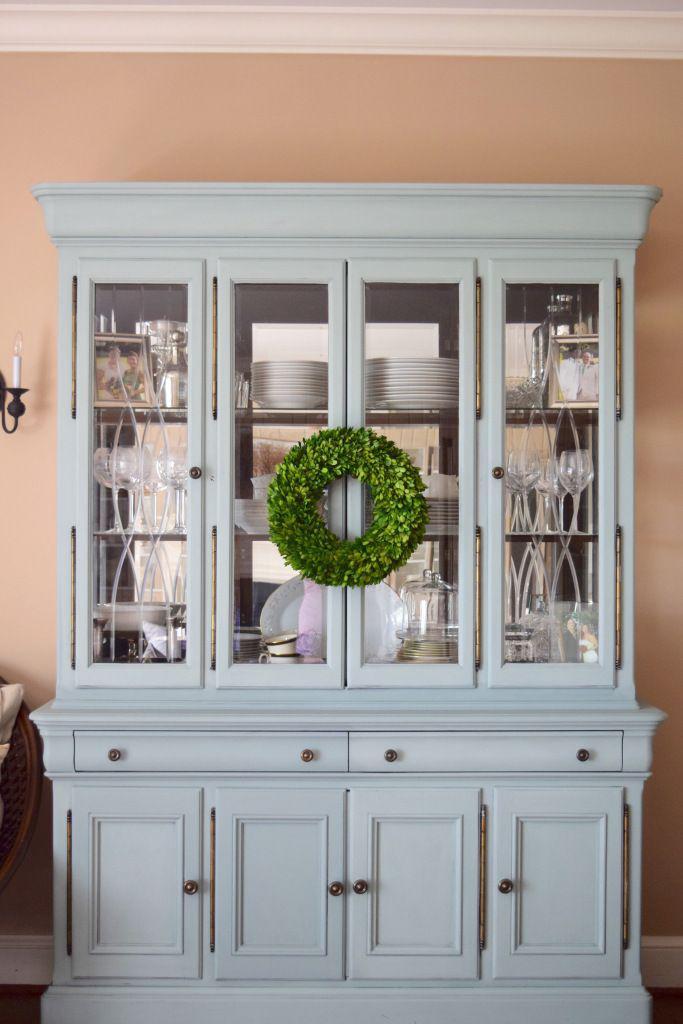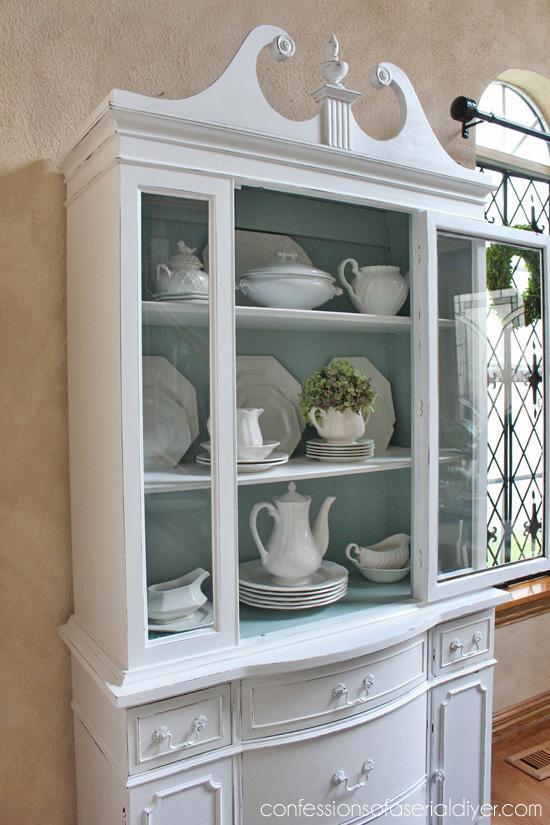The first image is the image on the left, the second image is the image on the right. Evaluate the accuracy of this statement regarding the images: "Both cabinets are filled with crockery.". Is it true? Answer yes or no. Yes. 